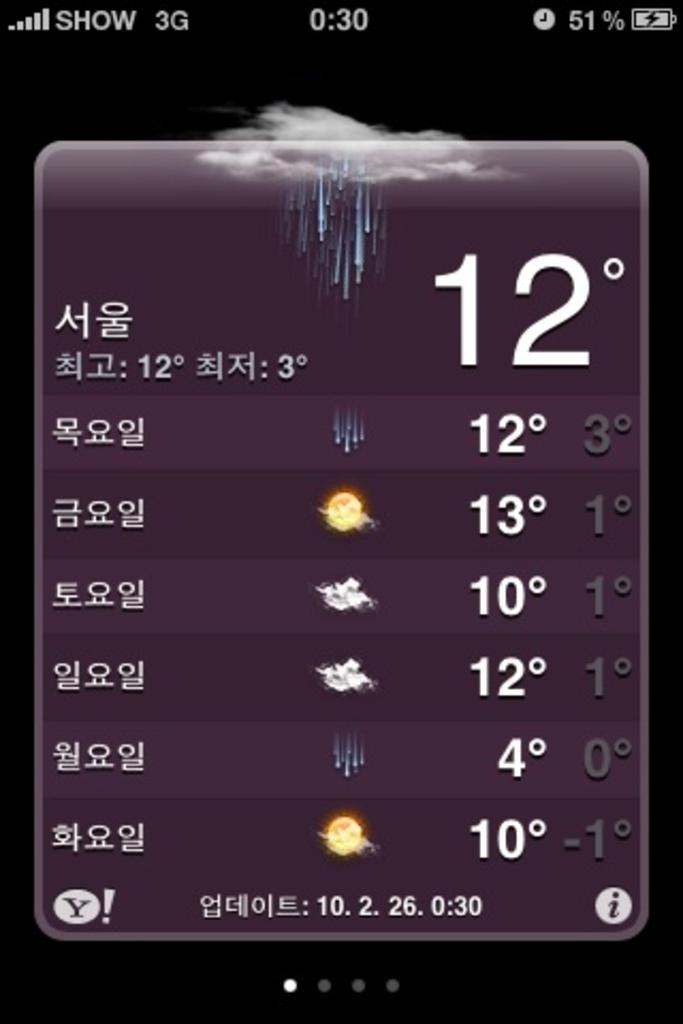What is the current temperature?
Give a very brief answer. 12. What's the lowest temperature?
Give a very brief answer. 4. 